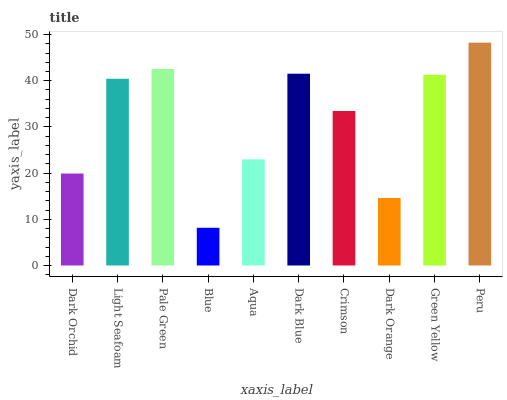Is Blue the minimum?
Answer yes or no. Yes. Is Peru the maximum?
Answer yes or no. Yes. Is Light Seafoam the minimum?
Answer yes or no. No. Is Light Seafoam the maximum?
Answer yes or no. No. Is Light Seafoam greater than Dark Orchid?
Answer yes or no. Yes. Is Dark Orchid less than Light Seafoam?
Answer yes or no. Yes. Is Dark Orchid greater than Light Seafoam?
Answer yes or no. No. Is Light Seafoam less than Dark Orchid?
Answer yes or no. No. Is Light Seafoam the high median?
Answer yes or no. Yes. Is Crimson the low median?
Answer yes or no. Yes. Is Blue the high median?
Answer yes or no. No. Is Pale Green the low median?
Answer yes or no. No. 